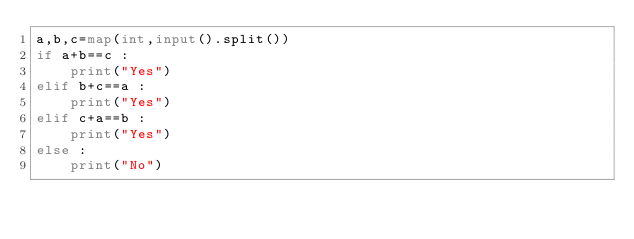<code> <loc_0><loc_0><loc_500><loc_500><_Python_>a,b,c=map(int,input().split())
if a+b==c :
    print("Yes")
elif b+c==a :
    print("Yes")
elif c+a==b :
    print("Yes")
else :
    print("No")</code> 